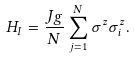<formula> <loc_0><loc_0><loc_500><loc_500>H _ { I } = \frac { J g } { N } \sum _ { j = 1 } ^ { N } \sigma ^ { z } \sigma _ { i } ^ { z } .</formula> 